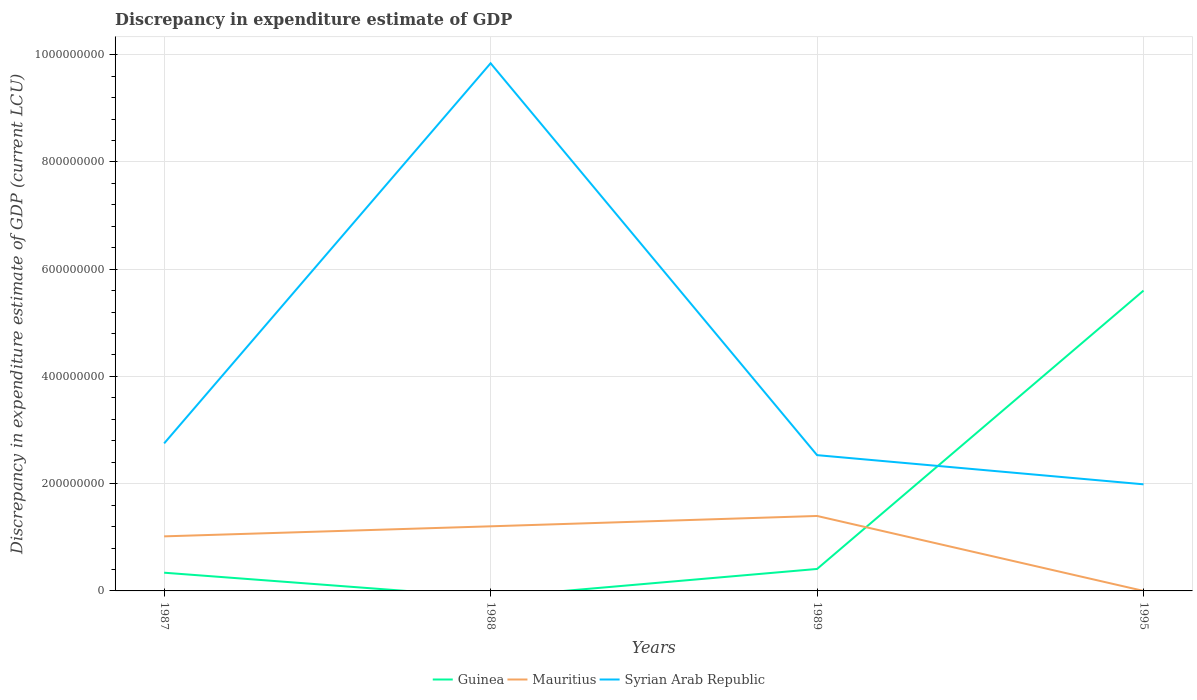Does the line corresponding to Mauritius intersect with the line corresponding to Syrian Arab Republic?
Make the answer very short. No. Is the number of lines equal to the number of legend labels?
Provide a short and direct response. No. Across all years, what is the maximum discrepancy in expenditure estimate of GDP in Mauritius?
Your answer should be very brief. 9.78e-5. What is the total discrepancy in expenditure estimate of GDP in Syrian Arab Republic in the graph?
Your answer should be compact. 7.85e+08. What is the difference between the highest and the second highest discrepancy in expenditure estimate of GDP in Syrian Arab Republic?
Keep it short and to the point. 7.85e+08. How many years are there in the graph?
Offer a terse response. 4. What is the difference between two consecutive major ticks on the Y-axis?
Your answer should be very brief. 2.00e+08. Does the graph contain grids?
Keep it short and to the point. Yes. How are the legend labels stacked?
Provide a succinct answer. Horizontal. What is the title of the graph?
Offer a very short reply. Discrepancy in expenditure estimate of GDP. What is the label or title of the X-axis?
Keep it short and to the point. Years. What is the label or title of the Y-axis?
Give a very brief answer. Discrepancy in expenditure estimate of GDP (current LCU). What is the Discrepancy in expenditure estimate of GDP (current LCU) of Guinea in 1987?
Your answer should be very brief. 3.40e+07. What is the Discrepancy in expenditure estimate of GDP (current LCU) in Mauritius in 1987?
Give a very brief answer. 1.02e+08. What is the Discrepancy in expenditure estimate of GDP (current LCU) of Syrian Arab Republic in 1987?
Your answer should be very brief. 2.75e+08. What is the Discrepancy in expenditure estimate of GDP (current LCU) in Mauritius in 1988?
Give a very brief answer. 1.21e+08. What is the Discrepancy in expenditure estimate of GDP (current LCU) in Syrian Arab Republic in 1988?
Provide a short and direct response. 9.84e+08. What is the Discrepancy in expenditure estimate of GDP (current LCU) in Guinea in 1989?
Offer a very short reply. 4.10e+07. What is the Discrepancy in expenditure estimate of GDP (current LCU) of Mauritius in 1989?
Make the answer very short. 1.40e+08. What is the Discrepancy in expenditure estimate of GDP (current LCU) of Syrian Arab Republic in 1989?
Keep it short and to the point. 2.53e+08. What is the Discrepancy in expenditure estimate of GDP (current LCU) of Guinea in 1995?
Provide a short and direct response. 5.60e+08. What is the Discrepancy in expenditure estimate of GDP (current LCU) in Mauritius in 1995?
Make the answer very short. 9.78e-5. What is the Discrepancy in expenditure estimate of GDP (current LCU) of Syrian Arab Republic in 1995?
Your answer should be very brief. 1.99e+08. Across all years, what is the maximum Discrepancy in expenditure estimate of GDP (current LCU) of Guinea?
Your response must be concise. 5.60e+08. Across all years, what is the maximum Discrepancy in expenditure estimate of GDP (current LCU) of Mauritius?
Your answer should be compact. 1.40e+08. Across all years, what is the maximum Discrepancy in expenditure estimate of GDP (current LCU) in Syrian Arab Republic?
Provide a short and direct response. 9.84e+08. Across all years, what is the minimum Discrepancy in expenditure estimate of GDP (current LCU) of Guinea?
Provide a succinct answer. 0. Across all years, what is the minimum Discrepancy in expenditure estimate of GDP (current LCU) in Mauritius?
Offer a terse response. 9.78e-5. Across all years, what is the minimum Discrepancy in expenditure estimate of GDP (current LCU) in Syrian Arab Republic?
Your response must be concise. 1.99e+08. What is the total Discrepancy in expenditure estimate of GDP (current LCU) of Guinea in the graph?
Provide a short and direct response. 6.35e+08. What is the total Discrepancy in expenditure estimate of GDP (current LCU) of Mauritius in the graph?
Provide a succinct answer. 3.62e+08. What is the total Discrepancy in expenditure estimate of GDP (current LCU) in Syrian Arab Republic in the graph?
Your answer should be compact. 1.71e+09. What is the difference between the Discrepancy in expenditure estimate of GDP (current LCU) in Mauritius in 1987 and that in 1988?
Offer a very short reply. -1.87e+07. What is the difference between the Discrepancy in expenditure estimate of GDP (current LCU) in Syrian Arab Republic in 1987 and that in 1988?
Your answer should be very brief. -7.09e+08. What is the difference between the Discrepancy in expenditure estimate of GDP (current LCU) of Guinea in 1987 and that in 1989?
Provide a succinct answer. -6.99e+06. What is the difference between the Discrepancy in expenditure estimate of GDP (current LCU) in Mauritius in 1987 and that in 1989?
Ensure brevity in your answer.  -3.80e+07. What is the difference between the Discrepancy in expenditure estimate of GDP (current LCU) of Syrian Arab Republic in 1987 and that in 1989?
Make the answer very short. 2.19e+07. What is the difference between the Discrepancy in expenditure estimate of GDP (current LCU) in Guinea in 1987 and that in 1995?
Provide a short and direct response. -5.26e+08. What is the difference between the Discrepancy in expenditure estimate of GDP (current LCU) in Mauritius in 1987 and that in 1995?
Your answer should be very brief. 1.02e+08. What is the difference between the Discrepancy in expenditure estimate of GDP (current LCU) of Syrian Arab Republic in 1987 and that in 1995?
Your answer should be compact. 7.63e+07. What is the difference between the Discrepancy in expenditure estimate of GDP (current LCU) in Mauritius in 1988 and that in 1989?
Keep it short and to the point. -1.93e+07. What is the difference between the Discrepancy in expenditure estimate of GDP (current LCU) in Syrian Arab Republic in 1988 and that in 1989?
Your answer should be compact. 7.31e+08. What is the difference between the Discrepancy in expenditure estimate of GDP (current LCU) of Mauritius in 1988 and that in 1995?
Your answer should be compact. 1.21e+08. What is the difference between the Discrepancy in expenditure estimate of GDP (current LCU) in Syrian Arab Republic in 1988 and that in 1995?
Offer a very short reply. 7.85e+08. What is the difference between the Discrepancy in expenditure estimate of GDP (current LCU) of Guinea in 1989 and that in 1995?
Keep it short and to the point. -5.19e+08. What is the difference between the Discrepancy in expenditure estimate of GDP (current LCU) of Mauritius in 1989 and that in 1995?
Provide a succinct answer. 1.40e+08. What is the difference between the Discrepancy in expenditure estimate of GDP (current LCU) in Syrian Arab Republic in 1989 and that in 1995?
Your response must be concise. 5.44e+07. What is the difference between the Discrepancy in expenditure estimate of GDP (current LCU) of Guinea in 1987 and the Discrepancy in expenditure estimate of GDP (current LCU) of Mauritius in 1988?
Keep it short and to the point. -8.65e+07. What is the difference between the Discrepancy in expenditure estimate of GDP (current LCU) in Guinea in 1987 and the Discrepancy in expenditure estimate of GDP (current LCU) in Syrian Arab Republic in 1988?
Make the answer very short. -9.50e+08. What is the difference between the Discrepancy in expenditure estimate of GDP (current LCU) in Mauritius in 1987 and the Discrepancy in expenditure estimate of GDP (current LCU) in Syrian Arab Republic in 1988?
Give a very brief answer. -8.82e+08. What is the difference between the Discrepancy in expenditure estimate of GDP (current LCU) of Guinea in 1987 and the Discrepancy in expenditure estimate of GDP (current LCU) of Mauritius in 1989?
Your answer should be compact. -1.06e+08. What is the difference between the Discrepancy in expenditure estimate of GDP (current LCU) in Guinea in 1987 and the Discrepancy in expenditure estimate of GDP (current LCU) in Syrian Arab Republic in 1989?
Provide a succinct answer. -2.19e+08. What is the difference between the Discrepancy in expenditure estimate of GDP (current LCU) of Mauritius in 1987 and the Discrepancy in expenditure estimate of GDP (current LCU) of Syrian Arab Republic in 1989?
Your answer should be compact. -1.51e+08. What is the difference between the Discrepancy in expenditure estimate of GDP (current LCU) of Guinea in 1987 and the Discrepancy in expenditure estimate of GDP (current LCU) of Mauritius in 1995?
Your response must be concise. 3.40e+07. What is the difference between the Discrepancy in expenditure estimate of GDP (current LCU) in Guinea in 1987 and the Discrepancy in expenditure estimate of GDP (current LCU) in Syrian Arab Republic in 1995?
Offer a terse response. -1.65e+08. What is the difference between the Discrepancy in expenditure estimate of GDP (current LCU) in Mauritius in 1987 and the Discrepancy in expenditure estimate of GDP (current LCU) in Syrian Arab Republic in 1995?
Keep it short and to the point. -9.70e+07. What is the difference between the Discrepancy in expenditure estimate of GDP (current LCU) in Mauritius in 1988 and the Discrepancy in expenditure estimate of GDP (current LCU) in Syrian Arab Republic in 1989?
Provide a succinct answer. -1.33e+08. What is the difference between the Discrepancy in expenditure estimate of GDP (current LCU) in Mauritius in 1988 and the Discrepancy in expenditure estimate of GDP (current LCU) in Syrian Arab Republic in 1995?
Your answer should be compact. -7.83e+07. What is the difference between the Discrepancy in expenditure estimate of GDP (current LCU) of Guinea in 1989 and the Discrepancy in expenditure estimate of GDP (current LCU) of Mauritius in 1995?
Provide a short and direct response. 4.10e+07. What is the difference between the Discrepancy in expenditure estimate of GDP (current LCU) of Guinea in 1989 and the Discrepancy in expenditure estimate of GDP (current LCU) of Syrian Arab Republic in 1995?
Your answer should be compact. -1.58e+08. What is the difference between the Discrepancy in expenditure estimate of GDP (current LCU) in Mauritius in 1989 and the Discrepancy in expenditure estimate of GDP (current LCU) in Syrian Arab Republic in 1995?
Give a very brief answer. -5.90e+07. What is the average Discrepancy in expenditure estimate of GDP (current LCU) in Guinea per year?
Offer a terse response. 1.59e+08. What is the average Discrepancy in expenditure estimate of GDP (current LCU) in Mauritius per year?
Your response must be concise. 9.05e+07. What is the average Discrepancy in expenditure estimate of GDP (current LCU) of Syrian Arab Republic per year?
Give a very brief answer. 4.28e+08. In the year 1987, what is the difference between the Discrepancy in expenditure estimate of GDP (current LCU) in Guinea and Discrepancy in expenditure estimate of GDP (current LCU) in Mauritius?
Ensure brevity in your answer.  -6.78e+07. In the year 1987, what is the difference between the Discrepancy in expenditure estimate of GDP (current LCU) in Guinea and Discrepancy in expenditure estimate of GDP (current LCU) in Syrian Arab Republic?
Keep it short and to the point. -2.41e+08. In the year 1987, what is the difference between the Discrepancy in expenditure estimate of GDP (current LCU) of Mauritius and Discrepancy in expenditure estimate of GDP (current LCU) of Syrian Arab Republic?
Offer a terse response. -1.73e+08. In the year 1988, what is the difference between the Discrepancy in expenditure estimate of GDP (current LCU) in Mauritius and Discrepancy in expenditure estimate of GDP (current LCU) in Syrian Arab Republic?
Provide a succinct answer. -8.63e+08. In the year 1989, what is the difference between the Discrepancy in expenditure estimate of GDP (current LCU) in Guinea and Discrepancy in expenditure estimate of GDP (current LCU) in Mauritius?
Ensure brevity in your answer.  -9.88e+07. In the year 1989, what is the difference between the Discrepancy in expenditure estimate of GDP (current LCU) in Guinea and Discrepancy in expenditure estimate of GDP (current LCU) in Syrian Arab Republic?
Offer a very short reply. -2.12e+08. In the year 1989, what is the difference between the Discrepancy in expenditure estimate of GDP (current LCU) of Mauritius and Discrepancy in expenditure estimate of GDP (current LCU) of Syrian Arab Republic?
Provide a succinct answer. -1.13e+08. In the year 1995, what is the difference between the Discrepancy in expenditure estimate of GDP (current LCU) of Guinea and Discrepancy in expenditure estimate of GDP (current LCU) of Mauritius?
Your response must be concise. 5.60e+08. In the year 1995, what is the difference between the Discrepancy in expenditure estimate of GDP (current LCU) in Guinea and Discrepancy in expenditure estimate of GDP (current LCU) in Syrian Arab Republic?
Keep it short and to the point. 3.61e+08. In the year 1995, what is the difference between the Discrepancy in expenditure estimate of GDP (current LCU) in Mauritius and Discrepancy in expenditure estimate of GDP (current LCU) in Syrian Arab Republic?
Offer a very short reply. -1.99e+08. What is the ratio of the Discrepancy in expenditure estimate of GDP (current LCU) of Mauritius in 1987 to that in 1988?
Your response must be concise. 0.84. What is the ratio of the Discrepancy in expenditure estimate of GDP (current LCU) in Syrian Arab Republic in 1987 to that in 1988?
Give a very brief answer. 0.28. What is the ratio of the Discrepancy in expenditure estimate of GDP (current LCU) of Guinea in 1987 to that in 1989?
Your answer should be compact. 0.83. What is the ratio of the Discrepancy in expenditure estimate of GDP (current LCU) in Mauritius in 1987 to that in 1989?
Provide a succinct answer. 0.73. What is the ratio of the Discrepancy in expenditure estimate of GDP (current LCU) in Syrian Arab Republic in 1987 to that in 1989?
Make the answer very short. 1.09. What is the ratio of the Discrepancy in expenditure estimate of GDP (current LCU) in Guinea in 1987 to that in 1995?
Your answer should be compact. 0.06. What is the ratio of the Discrepancy in expenditure estimate of GDP (current LCU) of Mauritius in 1987 to that in 1995?
Give a very brief answer. 1.04e+12. What is the ratio of the Discrepancy in expenditure estimate of GDP (current LCU) in Syrian Arab Republic in 1987 to that in 1995?
Offer a very short reply. 1.38. What is the ratio of the Discrepancy in expenditure estimate of GDP (current LCU) of Mauritius in 1988 to that in 1989?
Offer a terse response. 0.86. What is the ratio of the Discrepancy in expenditure estimate of GDP (current LCU) of Syrian Arab Republic in 1988 to that in 1989?
Offer a very short reply. 3.89. What is the ratio of the Discrepancy in expenditure estimate of GDP (current LCU) in Mauritius in 1988 to that in 1995?
Your answer should be compact. 1.23e+12. What is the ratio of the Discrepancy in expenditure estimate of GDP (current LCU) of Syrian Arab Republic in 1988 to that in 1995?
Offer a terse response. 4.95. What is the ratio of the Discrepancy in expenditure estimate of GDP (current LCU) in Guinea in 1989 to that in 1995?
Provide a short and direct response. 0.07. What is the ratio of the Discrepancy in expenditure estimate of GDP (current LCU) of Mauritius in 1989 to that in 1995?
Offer a terse response. 1.43e+12. What is the ratio of the Discrepancy in expenditure estimate of GDP (current LCU) of Syrian Arab Republic in 1989 to that in 1995?
Your answer should be compact. 1.27. What is the difference between the highest and the second highest Discrepancy in expenditure estimate of GDP (current LCU) in Guinea?
Your answer should be very brief. 5.19e+08. What is the difference between the highest and the second highest Discrepancy in expenditure estimate of GDP (current LCU) of Mauritius?
Offer a terse response. 1.93e+07. What is the difference between the highest and the second highest Discrepancy in expenditure estimate of GDP (current LCU) in Syrian Arab Republic?
Your answer should be compact. 7.09e+08. What is the difference between the highest and the lowest Discrepancy in expenditure estimate of GDP (current LCU) in Guinea?
Give a very brief answer. 5.60e+08. What is the difference between the highest and the lowest Discrepancy in expenditure estimate of GDP (current LCU) of Mauritius?
Offer a terse response. 1.40e+08. What is the difference between the highest and the lowest Discrepancy in expenditure estimate of GDP (current LCU) of Syrian Arab Republic?
Make the answer very short. 7.85e+08. 